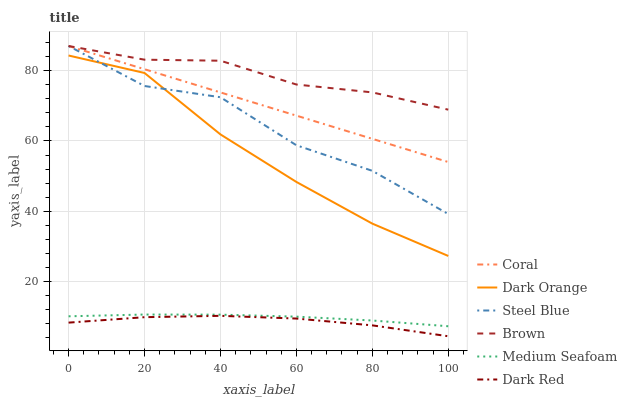Does Dark Red have the minimum area under the curve?
Answer yes or no. Yes. Does Brown have the maximum area under the curve?
Answer yes or no. Yes. Does Brown have the minimum area under the curve?
Answer yes or no. No. Does Dark Red have the maximum area under the curve?
Answer yes or no. No. Is Coral the smoothest?
Answer yes or no. Yes. Is Steel Blue the roughest?
Answer yes or no. Yes. Is Brown the smoothest?
Answer yes or no. No. Is Brown the roughest?
Answer yes or no. No. Does Dark Red have the lowest value?
Answer yes or no. Yes. Does Brown have the lowest value?
Answer yes or no. No. Does Steel Blue have the highest value?
Answer yes or no. Yes. Does Dark Red have the highest value?
Answer yes or no. No. Is Dark Red less than Dark Orange?
Answer yes or no. Yes. Is Dark Orange greater than Medium Seafoam?
Answer yes or no. Yes. Does Coral intersect Brown?
Answer yes or no. Yes. Is Coral less than Brown?
Answer yes or no. No. Is Coral greater than Brown?
Answer yes or no. No. Does Dark Red intersect Dark Orange?
Answer yes or no. No. 